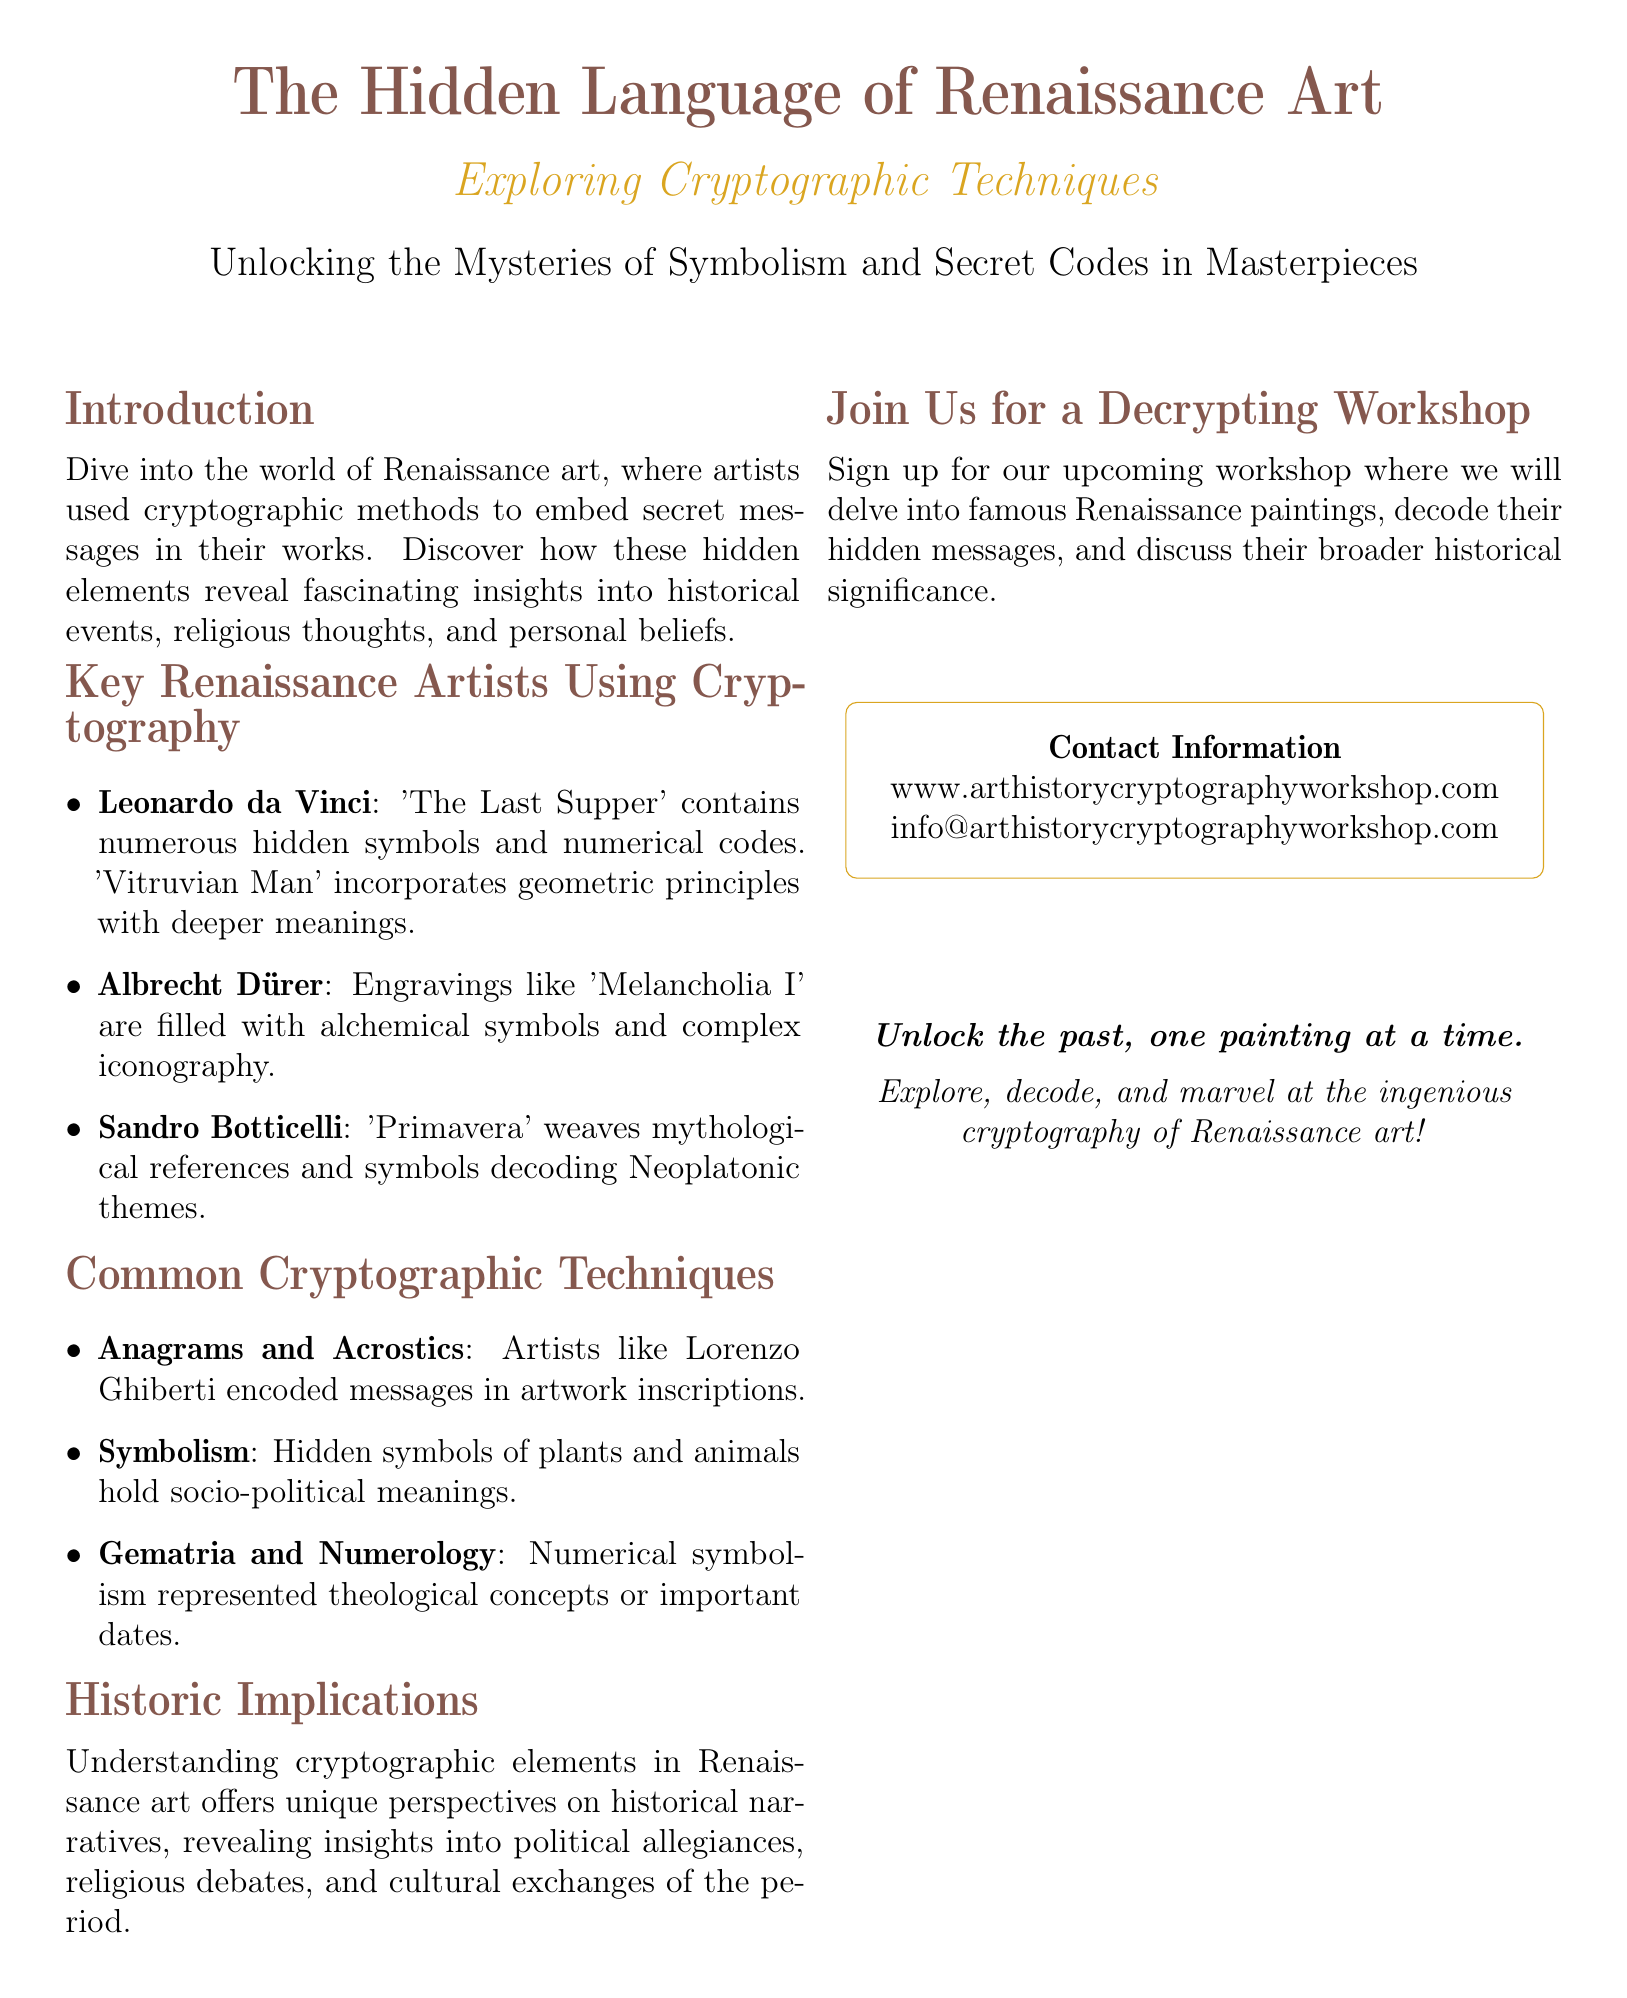What is the title of the event? The title of the event is clearly stated in the flyer as "The Hidden Language of Renaissance Art."
Answer: The Hidden Language of Renaissance Art Who is one artist mentioned that used cryptographic techniques? The flyer lists several artists, including Leonardo da Vinci as one who used cryptographic techniques.
Answer: Leonardo da Vinci What are common cryptographic techniques mentioned? The flyer lists several techniques, including Anagrams and Acrostics, Symbolism, and Gematria and Numerology.
Answer: Anagrams and Acrostics What does the introduction of the flyer mention about hidden elements in art? The introduction refers to hidden elements as revealing fascinating insights into historical events, religious thoughts, and personal beliefs.
Answer: Fascinating insights into historical events What is the contact website provided in the flyer? The document provides a contact website for more information and it is mentioned in the contact information section.
Answer: www.arthistorycryptographyworkshop.com How does understanding cryptographic elements in art affect historical narratives? The flyer states that understanding these elements offers unique perspectives on historical narratives.
Answer: Unique perspectives on historical narratives 